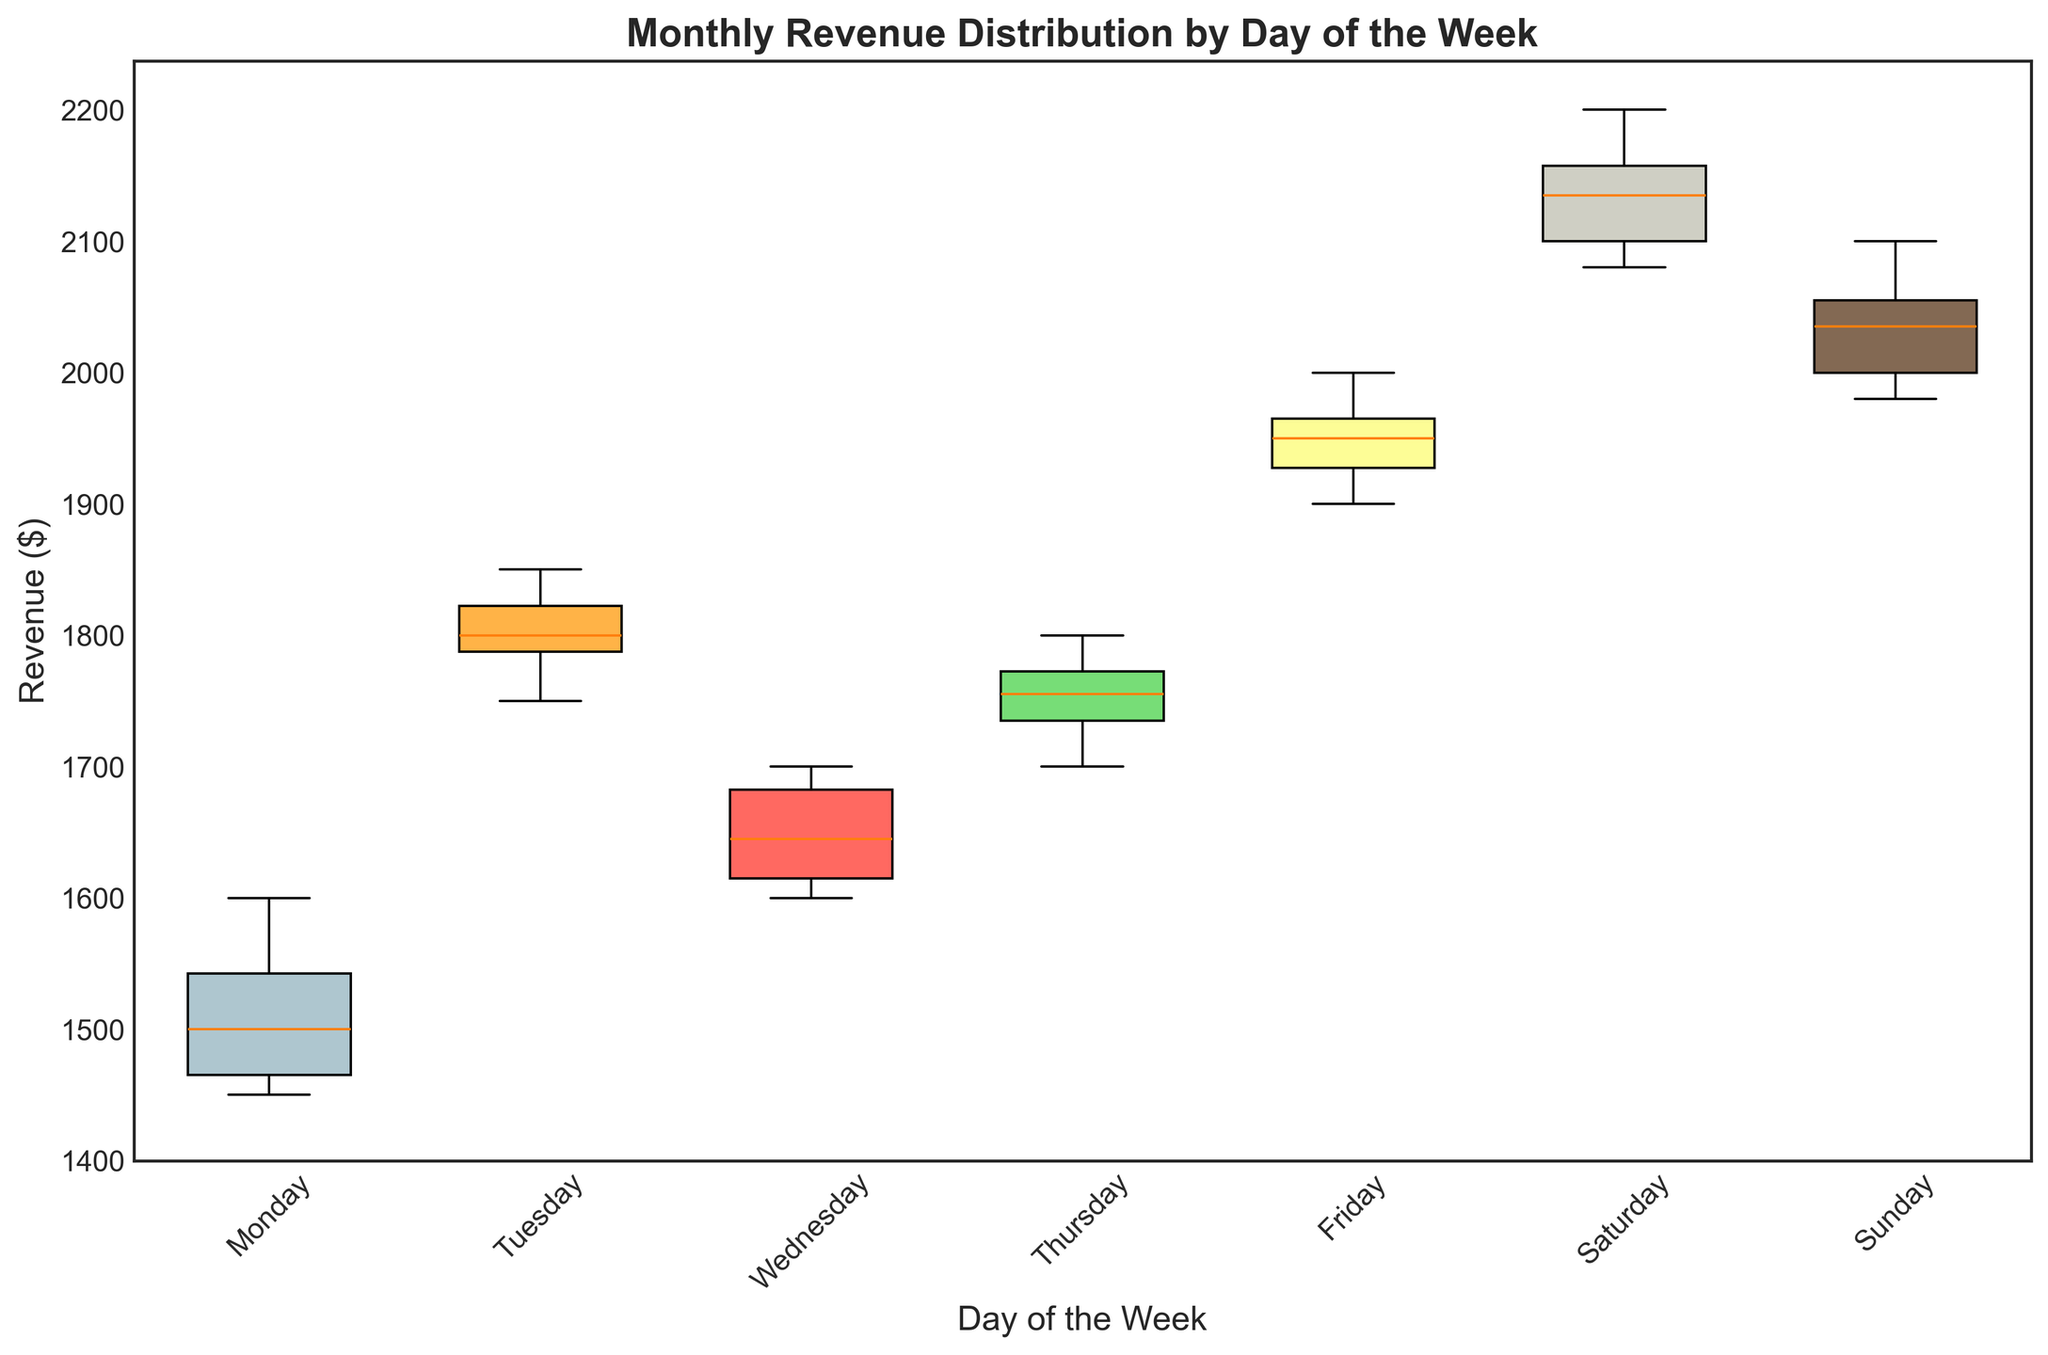Which day of the week has the highest median revenue? To determine the day with the highest median revenue, look at the central line within each box. Saturday has the highest central line, indicating the highest median revenue.
Answer: Saturday What is the interquartile range (IQR) for Tuesday's revenues? The IQR is the difference between the third quartile (Q3) and the first quartile (Q1). For Tuesday, identify the top and bottom edges of the box and subtract the bottom value from the top value. The values appear to be around 1830 (Q3) and 1790 (Q1), so the IQR is 1830 - 1790.
Answer: 40 Which day has the most consistent revenue? The most consistent revenue is indicated by the smallest box, which represents the shortest distance between Q1 and Q3. Monday's box is relatively smaller compared to other days, indicating the most consistent revenue.
Answer: Monday How does the revenue range on Sunday compare to Thursday? The range is the difference between the maximum and minimum values. For Sunday, it spans from approximately 1980 to 2100, while Thursday spans from approximately 1700 to 1800. Compute the ranges and compare. Sunday's range is 2100 - 1980 = 120, and Thursday's range is 1800 - 1700 = 100. Sunday has a larger revenue range.
Answer: Sunday has a larger range Between which days is the revenue distribution visually most different? Look at the boxes and whiskers, noting both their position and spread. Saturday and Monday show the most difference, with Saturday having the highest and widest distribution, and Monday having one of the lowest and smallest distributions.
Answer: Saturday and Monday What is the median revenue on Friday? Identify the central line within Friday's box. The median value looks to be around 1950.
Answer: 1950 What can be inferred about the revenue variance between Saturday and Wednesday? To infer variance, observe the spread of the boxes and whiskers. Saturday shows a wide distribution, indicating high variance. Wednesday has a narrower box and whiskers, suggesting lower variance.
Answer: Saturday has higher variance, Wednesday has lower variance Does any day have an outlier? Outliers are represented by individual points outside the whiskers. Checking each day, no points fall outside the whiskers, suggesting there are no outliers.
Answer: No What is the mean revenue for Thursday, considering the box plot information? While box plots show quartiles rather than exact means, we can roughly approximate the mean given the median and symmetry of the data. Thursday appears somewhat symmetric with the median around the middle of its box. So, the mean would be close to the median at approximately 1750+.
Answer: Approximately 1750+ Is Tuesday's median revenue higher than Sunday's lower quartile? Compare the central line of Tuesday to the bottom edge of Sunday's box. Tuesday's median appears to be higher than the bottom edge of Sunday's box (around 2000), indicating it is higher.
Answer: Yes, it is higher 